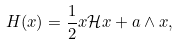<formula> <loc_0><loc_0><loc_500><loc_500>H ( x ) = \frac { 1 } { 2 } x \mathcal { H } x + a \wedge x ,</formula> 